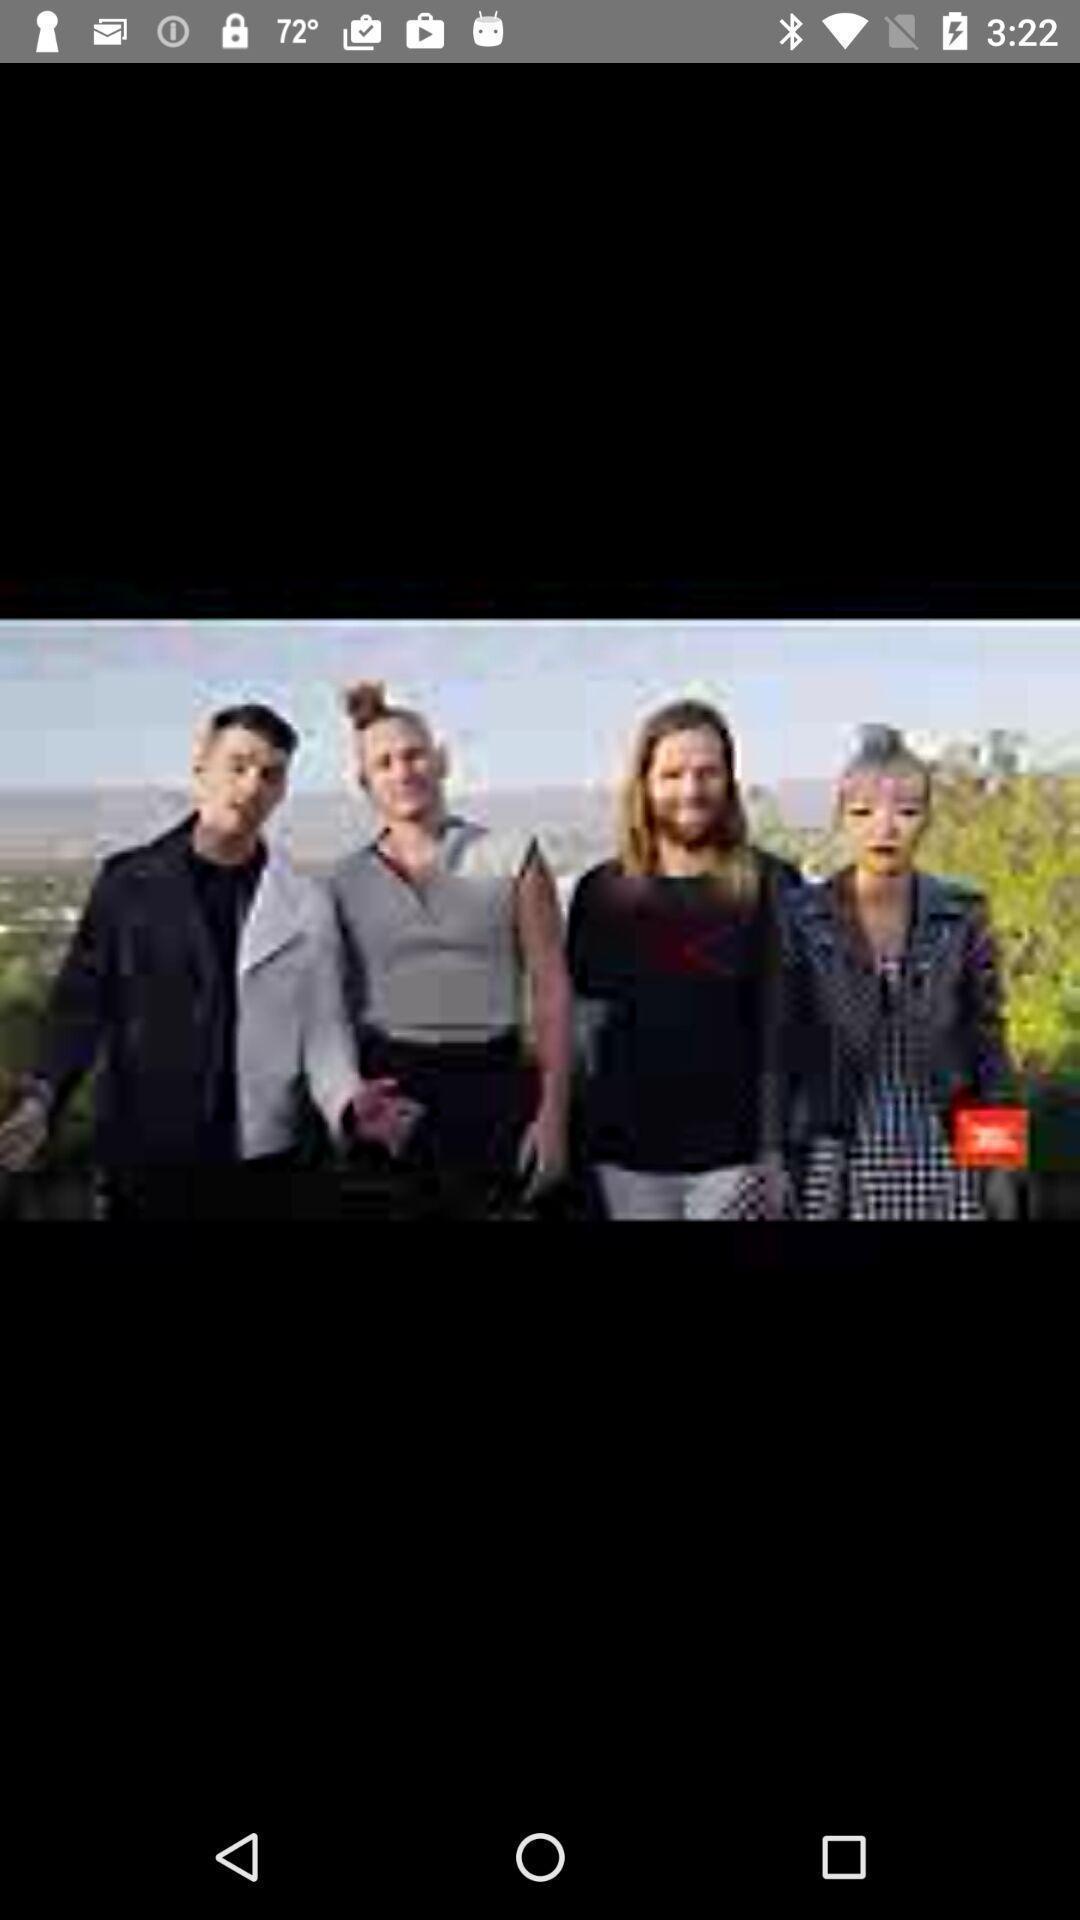Give me a narrative description of this picture. Page displaying with a image. 